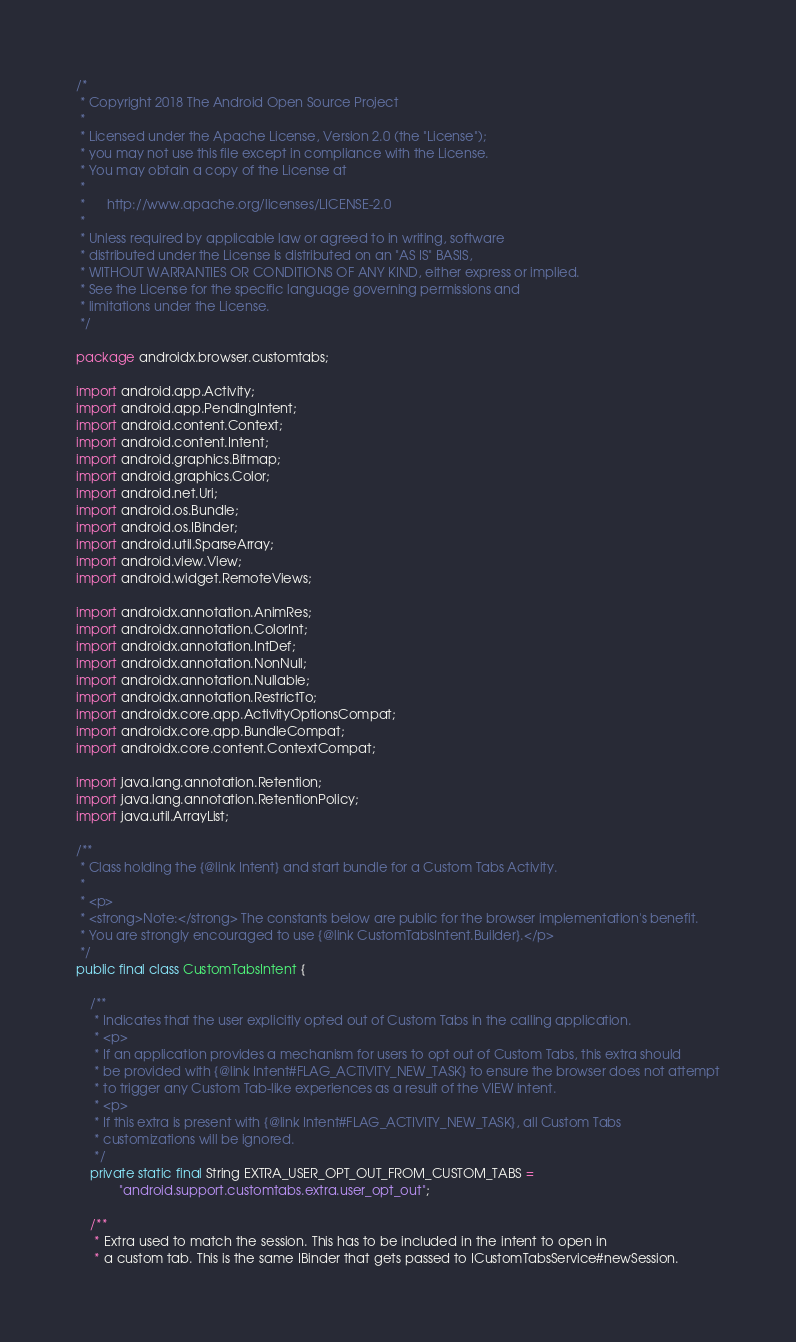Convert code to text. <code><loc_0><loc_0><loc_500><loc_500><_Java_>/*
 * Copyright 2018 The Android Open Source Project
 *
 * Licensed under the Apache License, Version 2.0 (the "License");
 * you may not use this file except in compliance with the License.
 * You may obtain a copy of the License at
 *
 *      http://www.apache.org/licenses/LICENSE-2.0
 *
 * Unless required by applicable law or agreed to in writing, software
 * distributed under the License is distributed on an "AS IS" BASIS,
 * WITHOUT WARRANTIES OR CONDITIONS OF ANY KIND, either express or implied.
 * See the License for the specific language governing permissions and
 * limitations under the License.
 */

package androidx.browser.customtabs;

import android.app.Activity;
import android.app.PendingIntent;
import android.content.Context;
import android.content.Intent;
import android.graphics.Bitmap;
import android.graphics.Color;
import android.net.Uri;
import android.os.Bundle;
import android.os.IBinder;
import android.util.SparseArray;
import android.view.View;
import android.widget.RemoteViews;

import androidx.annotation.AnimRes;
import androidx.annotation.ColorInt;
import androidx.annotation.IntDef;
import androidx.annotation.NonNull;
import androidx.annotation.Nullable;
import androidx.annotation.RestrictTo;
import androidx.core.app.ActivityOptionsCompat;
import androidx.core.app.BundleCompat;
import androidx.core.content.ContextCompat;

import java.lang.annotation.Retention;
import java.lang.annotation.RetentionPolicy;
import java.util.ArrayList;

/**
 * Class holding the {@link Intent} and start bundle for a Custom Tabs Activity.
 *
 * <p>
 * <strong>Note:</strong> The constants below are public for the browser implementation's benefit.
 * You are strongly encouraged to use {@link CustomTabsIntent.Builder}.</p>
 */
public final class CustomTabsIntent {

    /**
     * Indicates that the user explicitly opted out of Custom Tabs in the calling application.
     * <p>
     * If an application provides a mechanism for users to opt out of Custom Tabs, this extra should
     * be provided with {@link Intent#FLAG_ACTIVITY_NEW_TASK} to ensure the browser does not attempt
     * to trigger any Custom Tab-like experiences as a result of the VIEW intent.
     * <p>
     * If this extra is present with {@link Intent#FLAG_ACTIVITY_NEW_TASK}, all Custom Tabs
     * customizations will be ignored.
     */
    private static final String EXTRA_USER_OPT_OUT_FROM_CUSTOM_TABS =
            "android.support.customtabs.extra.user_opt_out";

    /**
     * Extra used to match the session. This has to be included in the intent to open in
     * a custom tab. This is the same IBinder that gets passed to ICustomTabsService#newSession.</code> 